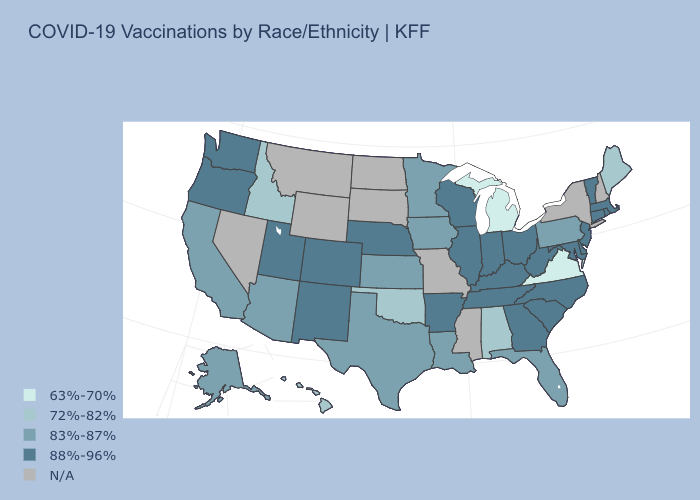Does Michigan have the lowest value in the USA?
Be succinct. Yes. What is the value of Missouri?
Short answer required. N/A. What is the value of Alabama?
Answer briefly. 72%-82%. Name the states that have a value in the range N/A?
Be succinct. Mississippi, Missouri, Montana, Nevada, New Hampshire, New York, North Dakota, South Dakota, Wyoming. Which states have the lowest value in the South?
Write a very short answer. Virginia. Is the legend a continuous bar?
Be succinct. No. Does the first symbol in the legend represent the smallest category?
Concise answer only. Yes. Name the states that have a value in the range 83%-87%?
Answer briefly. Alaska, Arizona, California, Florida, Iowa, Kansas, Louisiana, Minnesota, Pennsylvania, Texas. What is the value of Connecticut?
Short answer required. 88%-96%. Name the states that have a value in the range N/A?
Keep it brief. Mississippi, Missouri, Montana, Nevada, New Hampshire, New York, North Dakota, South Dakota, Wyoming. What is the value of Florida?
Be succinct. 83%-87%. Does the first symbol in the legend represent the smallest category?
Concise answer only. Yes. Does South Carolina have the highest value in the USA?
Give a very brief answer. Yes. 